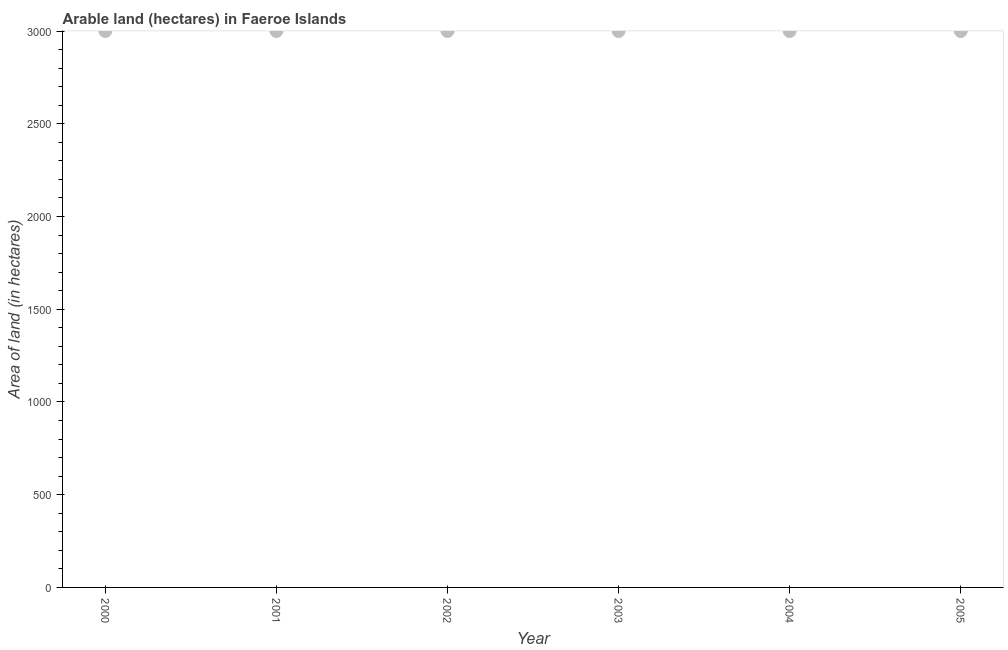What is the area of land in 2000?
Provide a short and direct response. 3000. Across all years, what is the maximum area of land?
Offer a very short reply. 3000. Across all years, what is the minimum area of land?
Your answer should be compact. 3000. In which year was the area of land maximum?
Provide a short and direct response. 2000. What is the sum of the area of land?
Make the answer very short. 1.80e+04. What is the difference between the area of land in 2000 and 2001?
Provide a succinct answer. 0. What is the average area of land per year?
Your response must be concise. 3000. What is the median area of land?
Provide a short and direct response. 3000. In how many years, is the area of land greater than 2400 hectares?
Keep it short and to the point. 6. Is the area of land in 2001 less than that in 2005?
Keep it short and to the point. No. Is the sum of the area of land in 2000 and 2003 greater than the maximum area of land across all years?
Ensure brevity in your answer.  Yes. In how many years, is the area of land greater than the average area of land taken over all years?
Make the answer very short. 0. Does the area of land monotonically increase over the years?
Give a very brief answer. No. How many dotlines are there?
Provide a succinct answer. 1. What is the difference between two consecutive major ticks on the Y-axis?
Provide a short and direct response. 500. Does the graph contain any zero values?
Make the answer very short. No. What is the title of the graph?
Keep it short and to the point. Arable land (hectares) in Faeroe Islands. What is the label or title of the X-axis?
Offer a very short reply. Year. What is the label or title of the Y-axis?
Ensure brevity in your answer.  Area of land (in hectares). What is the Area of land (in hectares) in 2000?
Ensure brevity in your answer.  3000. What is the Area of land (in hectares) in 2001?
Give a very brief answer. 3000. What is the Area of land (in hectares) in 2002?
Provide a succinct answer. 3000. What is the Area of land (in hectares) in 2003?
Offer a terse response. 3000. What is the Area of land (in hectares) in 2004?
Give a very brief answer. 3000. What is the Area of land (in hectares) in 2005?
Keep it short and to the point. 3000. What is the difference between the Area of land (in hectares) in 2000 and 2001?
Keep it short and to the point. 0. What is the difference between the Area of land (in hectares) in 2000 and 2003?
Offer a terse response. 0. What is the difference between the Area of land (in hectares) in 2000 and 2005?
Your answer should be very brief. 0. What is the difference between the Area of land (in hectares) in 2001 and 2002?
Give a very brief answer. 0. What is the difference between the Area of land (in hectares) in 2001 and 2003?
Offer a terse response. 0. What is the difference between the Area of land (in hectares) in 2001 and 2005?
Your answer should be very brief. 0. What is the difference between the Area of land (in hectares) in 2002 and 2003?
Give a very brief answer. 0. What is the difference between the Area of land (in hectares) in 2002 and 2004?
Your answer should be compact. 0. What is the difference between the Area of land (in hectares) in 2003 and 2005?
Provide a short and direct response. 0. What is the difference between the Area of land (in hectares) in 2004 and 2005?
Your answer should be compact. 0. What is the ratio of the Area of land (in hectares) in 2000 to that in 2002?
Give a very brief answer. 1. What is the ratio of the Area of land (in hectares) in 2000 to that in 2003?
Offer a terse response. 1. What is the ratio of the Area of land (in hectares) in 2001 to that in 2004?
Offer a terse response. 1. What is the ratio of the Area of land (in hectares) in 2002 to that in 2003?
Your answer should be very brief. 1. What is the ratio of the Area of land (in hectares) in 2002 to that in 2004?
Ensure brevity in your answer.  1. What is the ratio of the Area of land (in hectares) in 2003 to that in 2004?
Your response must be concise. 1. What is the ratio of the Area of land (in hectares) in 2003 to that in 2005?
Your answer should be very brief. 1. What is the ratio of the Area of land (in hectares) in 2004 to that in 2005?
Keep it short and to the point. 1. 